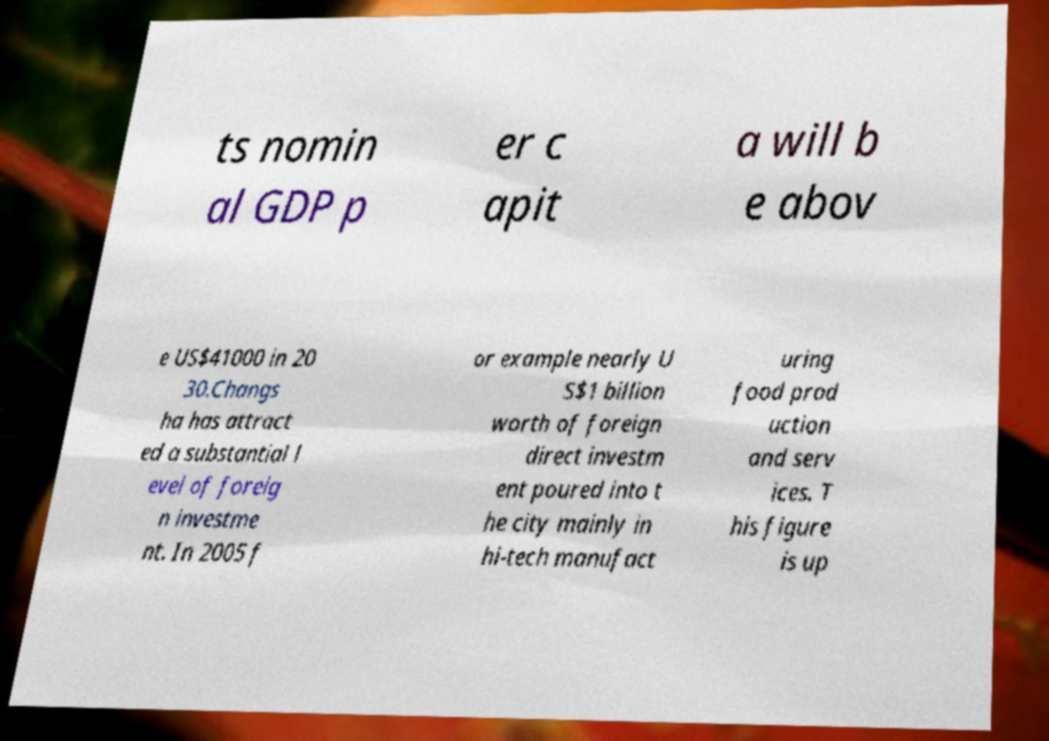Please read and relay the text visible in this image. What does it say? ts nomin al GDP p er c apit a will b e abov e US$41000 in 20 30.Changs ha has attract ed a substantial l evel of foreig n investme nt. In 2005 f or example nearly U S$1 billion worth of foreign direct investm ent poured into t he city mainly in hi-tech manufact uring food prod uction and serv ices. T his figure is up 